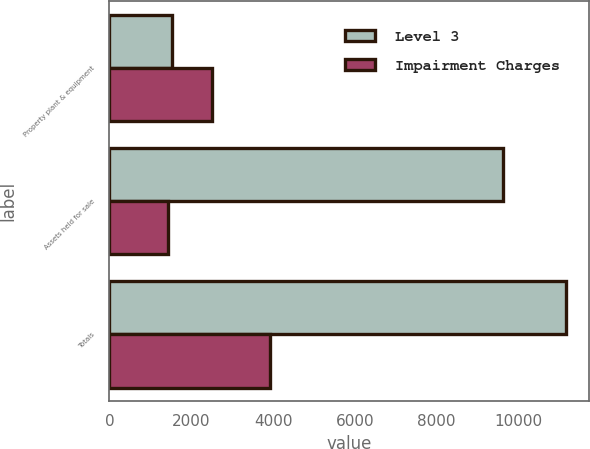Convert chart. <chart><loc_0><loc_0><loc_500><loc_500><stacked_bar_chart><ecel><fcel>Property plant & equipment<fcel>Assets held for sale<fcel>Totals<nl><fcel>Level 3<fcel>1536<fcel>9625<fcel>11161<nl><fcel>Impairment Charges<fcel>2500<fcel>1436<fcel>3936<nl></chart> 